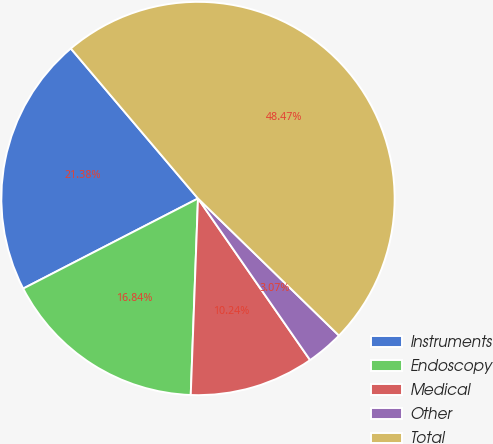Convert chart to OTSL. <chart><loc_0><loc_0><loc_500><loc_500><pie_chart><fcel>Instruments<fcel>Endoscopy<fcel>Medical<fcel>Other<fcel>Total<nl><fcel>21.38%<fcel>16.84%<fcel>10.24%<fcel>3.07%<fcel>48.47%<nl></chart> 